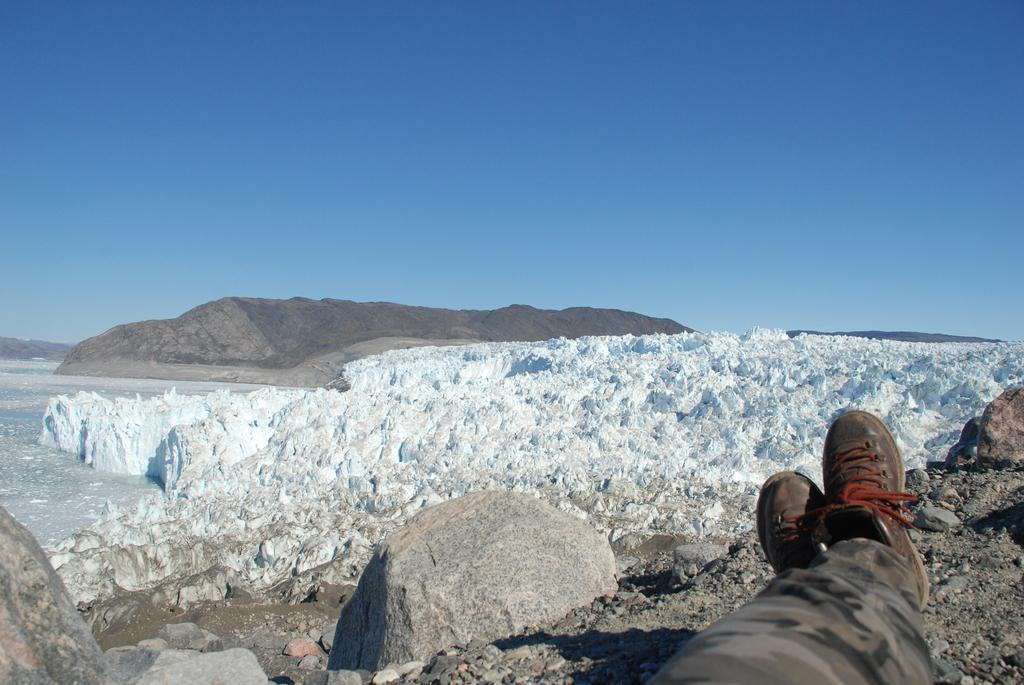What objects can be seen on the ground in the image? There are shoes visible in the image. What else can be seen on the ground in the image? There are legs of a person in the image. What can be seen in the distance in the image? There are rocks and hills in the background of the image. What type of bulb is growing in the grass in the image? There is no grass or bulb present in the image. How many feet can be seen in the image? There is only one set of legs visible in the image, which corresponds to one pair of feet. 